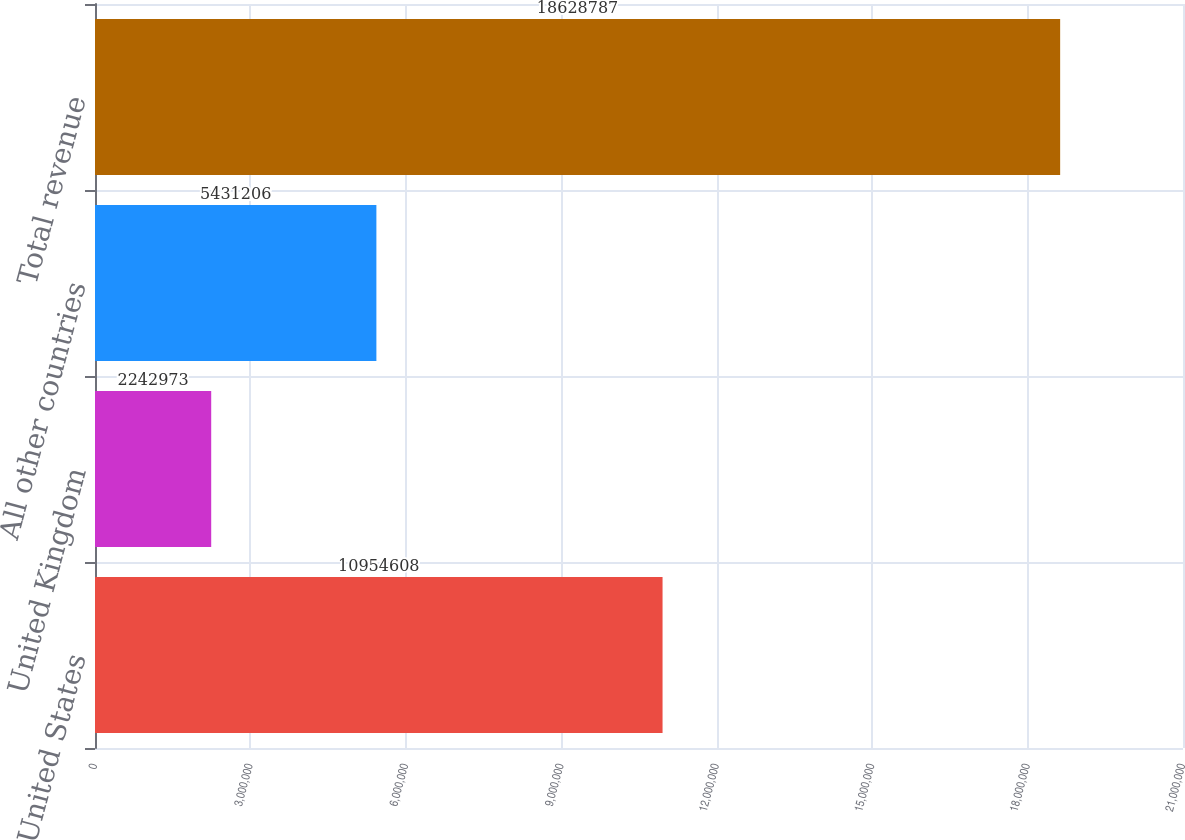Convert chart. <chart><loc_0><loc_0><loc_500><loc_500><bar_chart><fcel>United States<fcel>United Kingdom<fcel>All other countries<fcel>Total revenue<nl><fcel>1.09546e+07<fcel>2.24297e+06<fcel>5.43121e+06<fcel>1.86288e+07<nl></chart> 